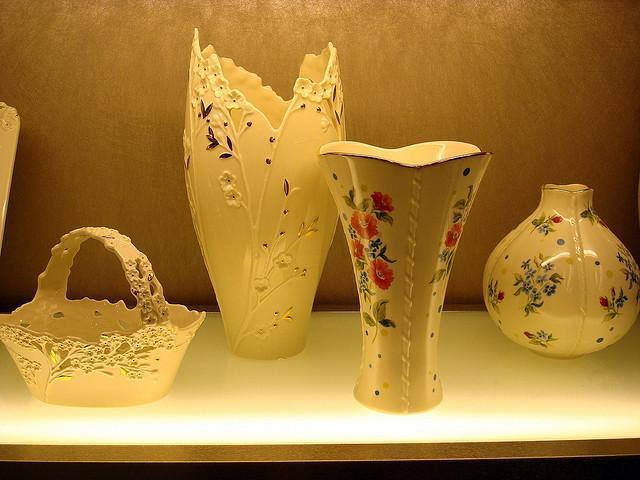How many vases are in the picture?
Give a very brief answer. 3. How many vases have a handle on them?
Give a very brief answer. 1. How many vases are there?
Give a very brief answer. 4. 